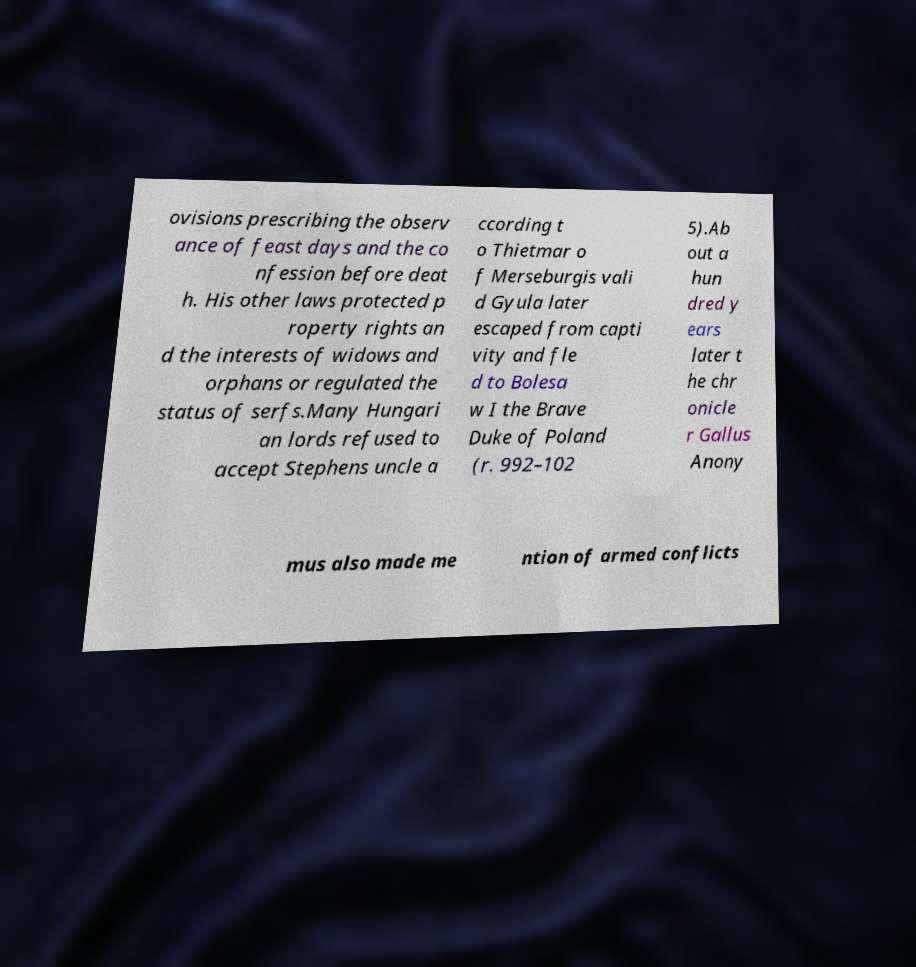Can you read and provide the text displayed in the image?This photo seems to have some interesting text. Can you extract and type it out for me? ovisions prescribing the observ ance of feast days and the co nfession before deat h. His other laws protected p roperty rights an d the interests of widows and orphans or regulated the status of serfs.Many Hungari an lords refused to accept Stephens uncle a ccording t o Thietmar o f Merseburgis vali d Gyula later escaped from capti vity and fle d to Bolesa w I the Brave Duke of Poland (r. 992–102 5).Ab out a hun dred y ears later t he chr onicle r Gallus Anony mus also made me ntion of armed conflicts 